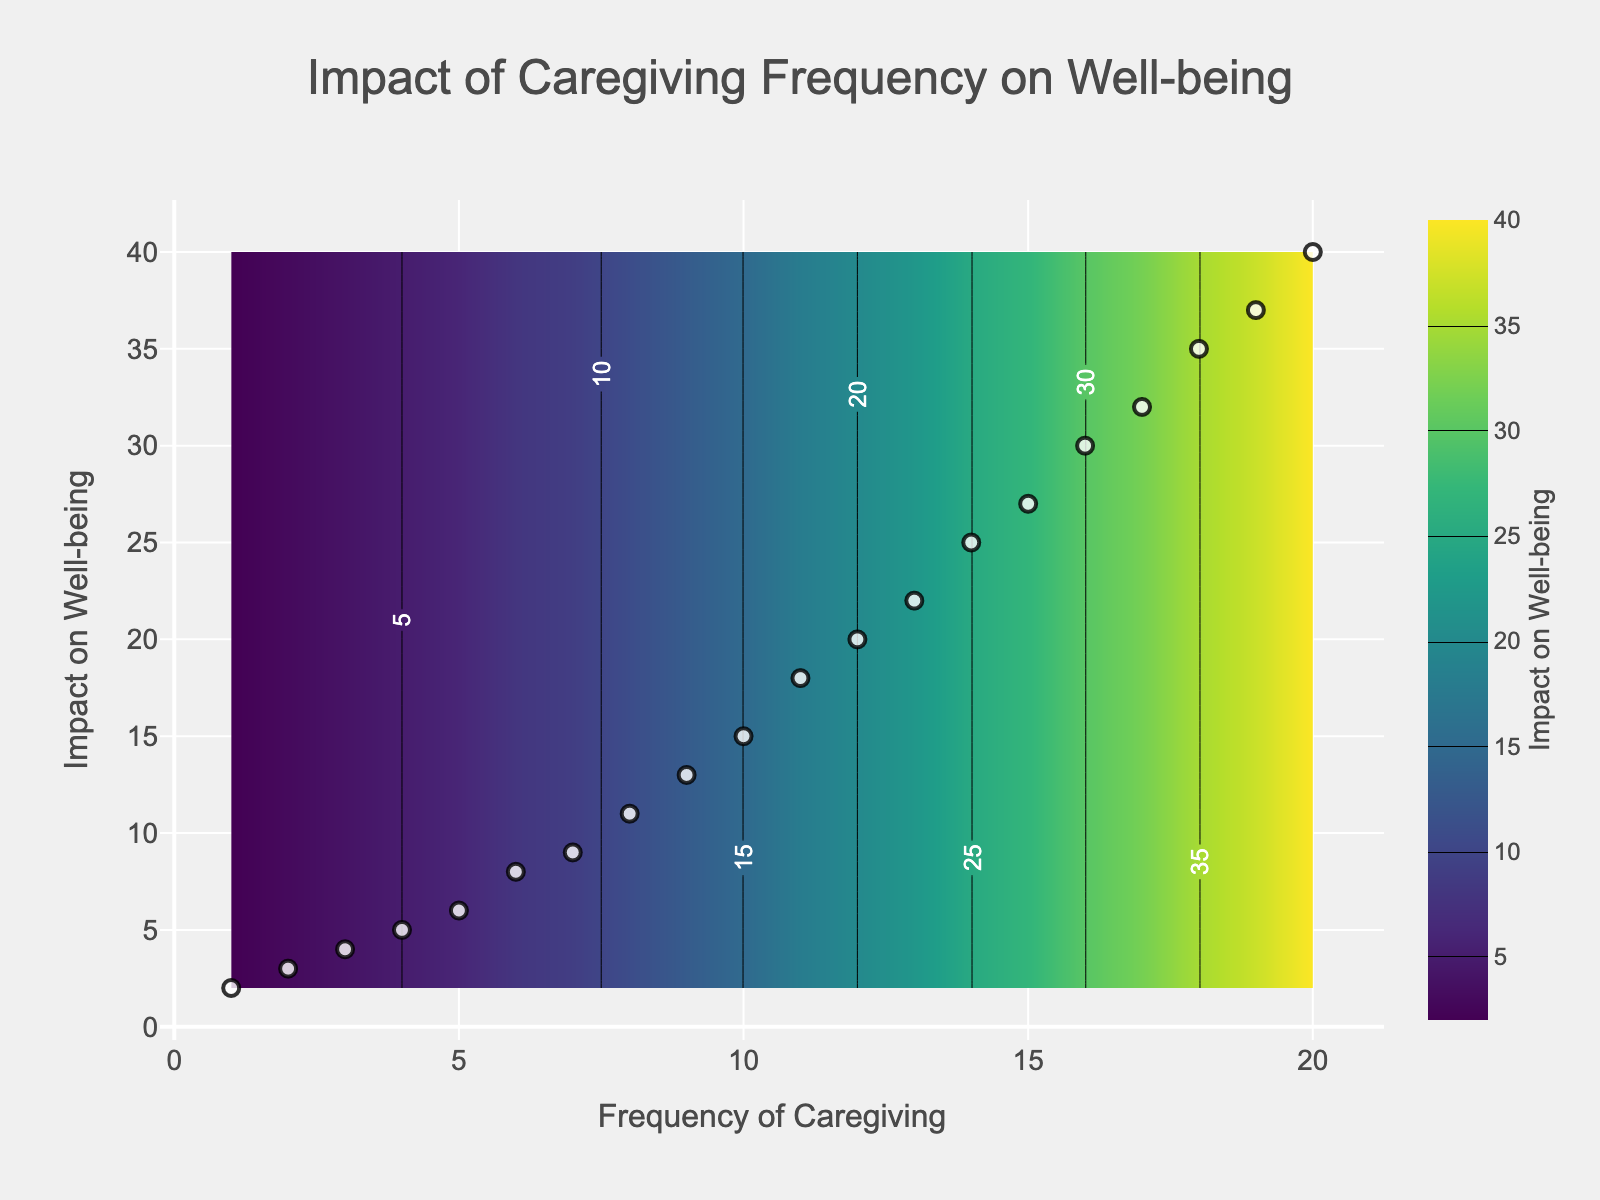How many data points are shown in the scatter plot? To determine the number of data points, look at the scatter points overlayed on the contour plot. Each white dot represents a data point. Counting these, we find there are 20 data points.
Answer: 20 What are the variables represented on the x and y axes? The x-axis represents "Frequency of Caregiving" and the y-axis represents "Impact on Well-being," as indicated by the labels along the respective axes.
Answer: Frequency of Caregiving and Impact on Well-being What is the title of the plot? The title is typically displayed at the top of the plot. In this case, it reads, "Impact of Caregiving Frequency on Well-being."
Answer: Impact of Caregiving Frequency on Well-being Which caregiving frequency has the highest impact on well-being visible in the data points? By identifying the highest value on the y-axis among the scatter points which represent the impact, we see that a frequency of 20 has the highest impact with a value of 40.
Answer: 20 At a caregiving frequency of 8, what is the impact on well-being? Locate the scatter point at the x-axis value of 8. Trace vertically to intersect with the y-axis to find the impact, which is 11.
Answer: 11 What is the color scheme used in the contour plot? The contour plot uses the Viridis color scheme, which transitions from dark purple to yellow, as can be observed from the gradient and the color bar.
Answer: Viridis What is the range of the well-being impact values represented in the plot? The range can be determined by looking at the minimum and maximum values on the y-axis, which are from 2 to 40.
Answer: 2 to 40 Compare the impact on well-being at caregiving frequencies of 5 and 10. By identifying the y-axis values for x-axis values 5 and 10, we see that at a frequency of 5, the impact is 6, and at 10, the impact is 15. A frequency of 10 has a higher impact on well-being.
Answer: 10 is higher If the caregiving frequency is doubled from 6 to 12, how does the impact on well-being change? Locate the impacts corresponding to frequencies 6 and 12. Initially, the impact is 8. When the frequency doubles to 12, the impact increases to 20, showing an increase of 12.
Answer: Increases by 12 How would you describe the trend in the relationship between caregiving frequency and well-being impact? Observing the data points and contour lines, there is a positive correlation where higher caregiving frequencies are associated with higher impacts on well-being, indicating a direct relationship.
Answer: Positive correlation 